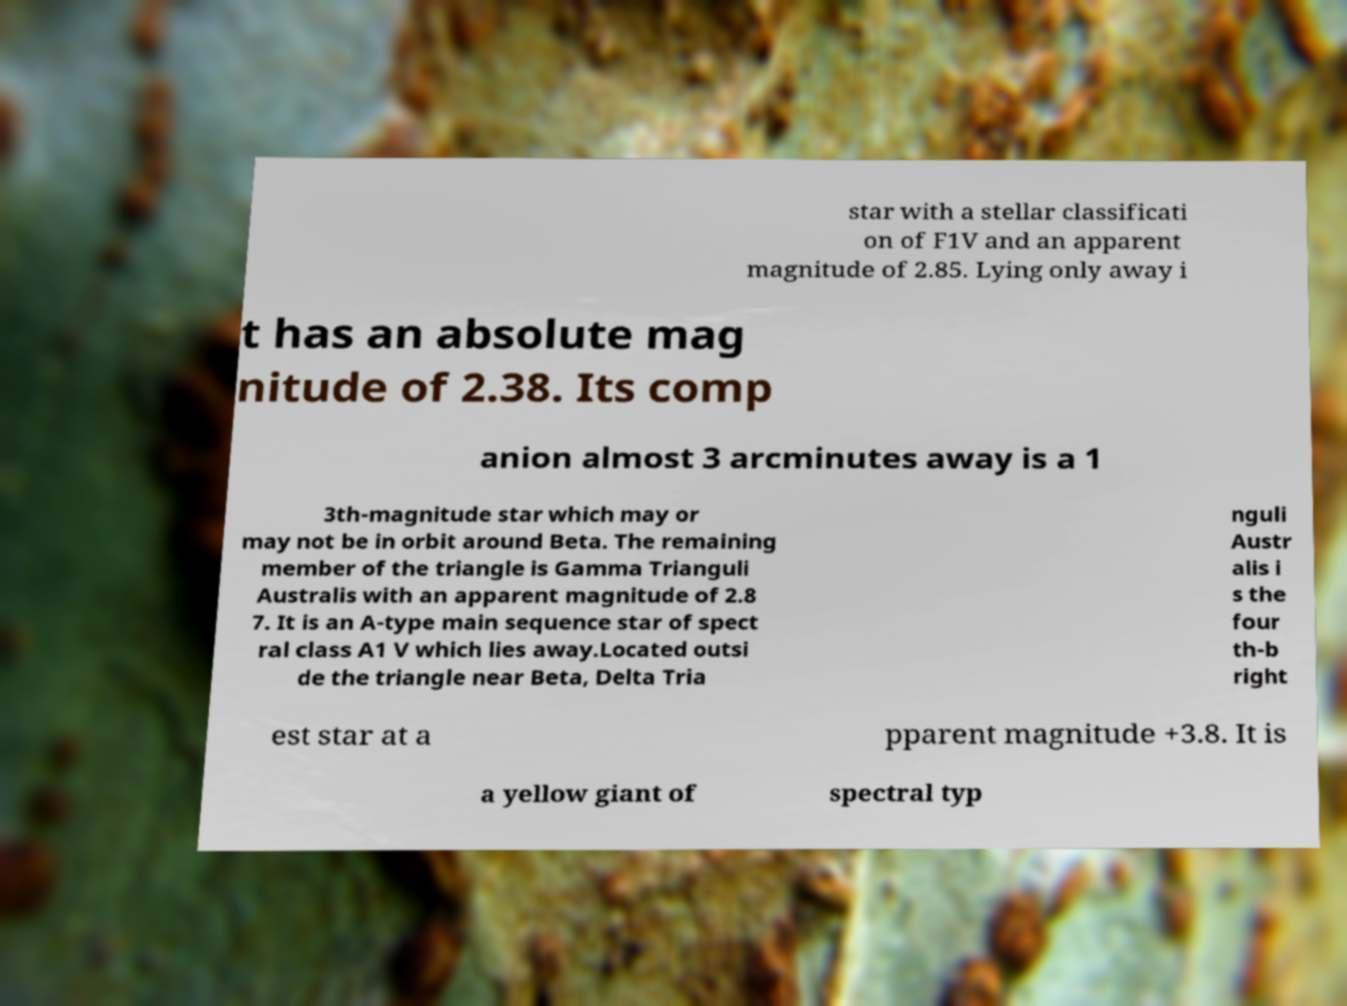There's text embedded in this image that I need extracted. Can you transcribe it verbatim? star with a stellar classificati on of F1V and an apparent magnitude of 2.85. Lying only away i t has an absolute mag nitude of 2.38. Its comp anion almost 3 arcminutes away is a 1 3th-magnitude star which may or may not be in orbit around Beta. The remaining member of the triangle is Gamma Trianguli Australis with an apparent magnitude of 2.8 7. It is an A-type main sequence star of spect ral class A1 V which lies away.Located outsi de the triangle near Beta, Delta Tria nguli Austr alis i s the four th-b right est star at a pparent magnitude +3.8. It is a yellow giant of spectral typ 